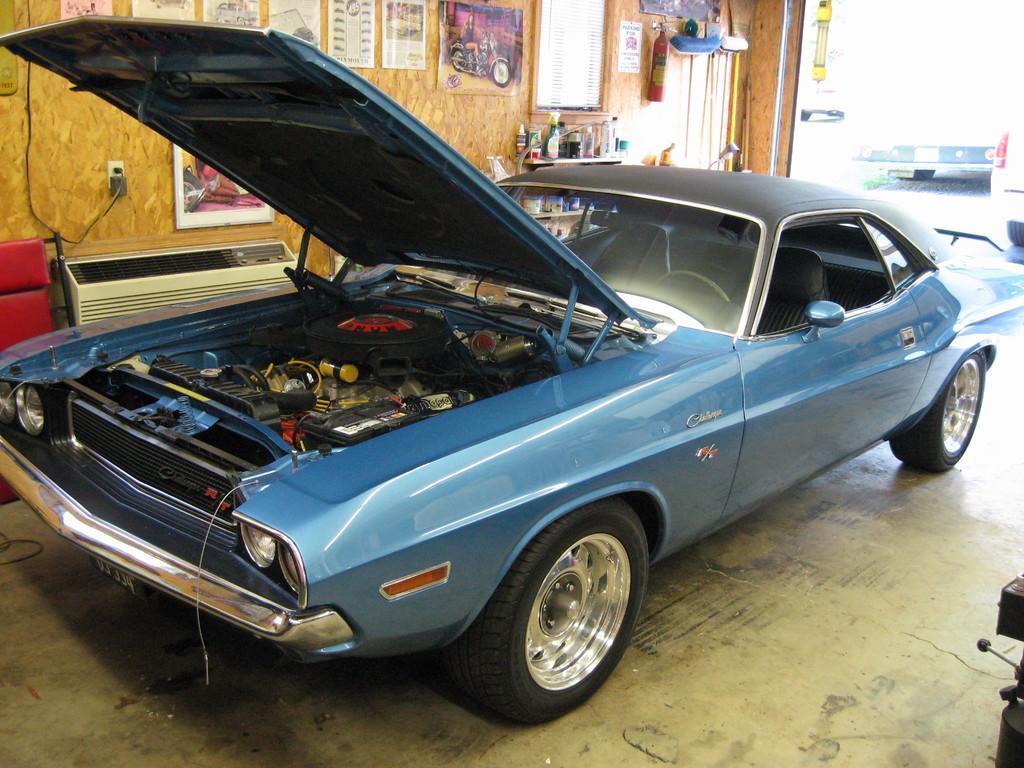Describe this image in one or two sentences. In this image I can see the vehicle which is in blue color. To the side of the vehicle I can see many boards, papers and fire extinguisher to the wooden wall. I can see also see some machines and many bottles on the table. In the background I can see few more vehicles. 